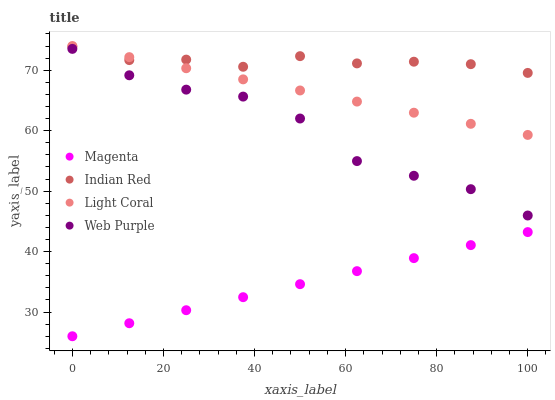Does Magenta have the minimum area under the curve?
Answer yes or no. Yes. Does Indian Red have the maximum area under the curve?
Answer yes or no. Yes. Does Web Purple have the minimum area under the curve?
Answer yes or no. No. Does Web Purple have the maximum area under the curve?
Answer yes or no. No. Is Magenta the smoothest?
Answer yes or no. Yes. Is Web Purple the roughest?
Answer yes or no. Yes. Is Web Purple the smoothest?
Answer yes or no. No. Is Magenta the roughest?
Answer yes or no. No. Does Magenta have the lowest value?
Answer yes or no. Yes. Does Web Purple have the lowest value?
Answer yes or no. No. Does Light Coral have the highest value?
Answer yes or no. Yes. Does Web Purple have the highest value?
Answer yes or no. No. Is Web Purple less than Light Coral?
Answer yes or no. Yes. Is Indian Red greater than Web Purple?
Answer yes or no. Yes. Does Indian Red intersect Light Coral?
Answer yes or no. Yes. Is Indian Red less than Light Coral?
Answer yes or no. No. Is Indian Red greater than Light Coral?
Answer yes or no. No. Does Web Purple intersect Light Coral?
Answer yes or no. No. 